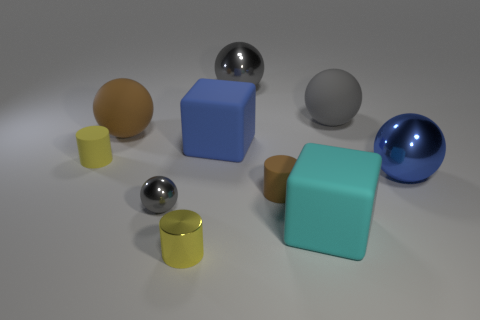Subtract all purple blocks. How many gray balls are left? 3 Subtract 1 balls. How many balls are left? 4 Subtract all big brown matte spheres. How many spheres are left? 4 Subtract all blue balls. How many balls are left? 4 Subtract all green spheres. Subtract all blue cylinders. How many spheres are left? 5 Subtract all cylinders. How many objects are left? 7 Add 7 tiny yellow matte cylinders. How many tiny yellow matte cylinders are left? 8 Add 4 small cylinders. How many small cylinders exist? 7 Subtract 0 red blocks. How many objects are left? 10 Subtract all blue matte blocks. Subtract all big objects. How many objects are left? 3 